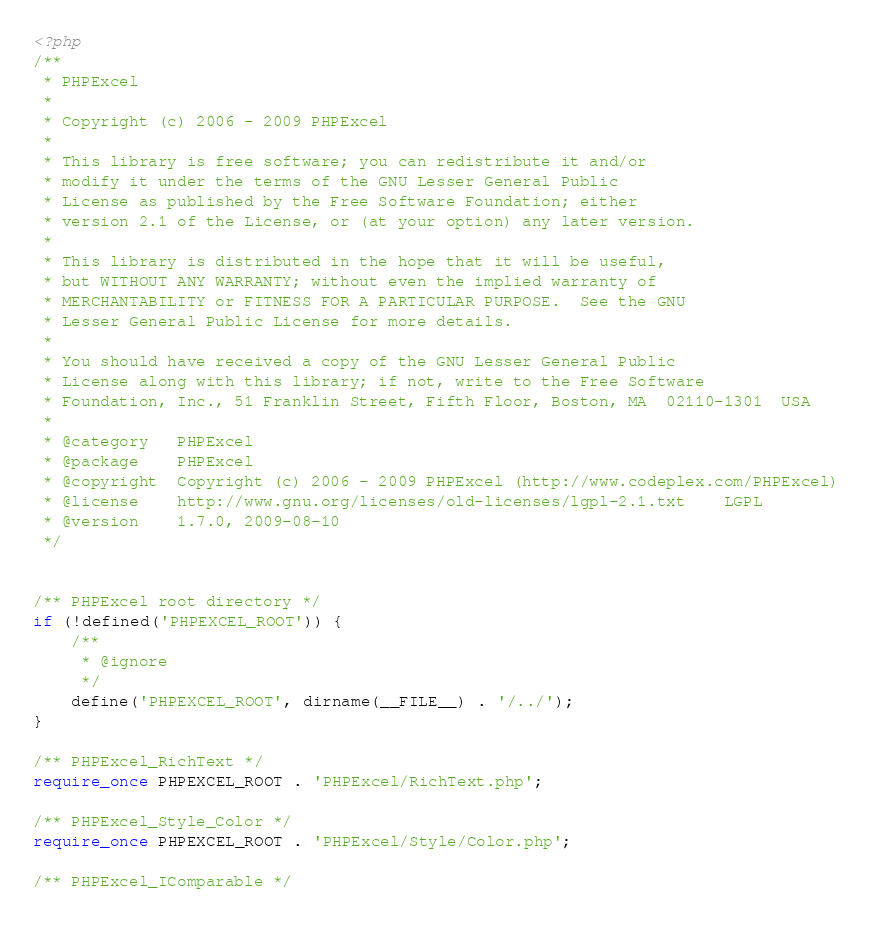<code> <loc_0><loc_0><loc_500><loc_500><_PHP_><?php
/**
 * PHPExcel
 *
 * Copyright (c) 2006 - 2009 PHPExcel
 *
 * This library is free software; you can redistribute it and/or
 * modify it under the terms of the GNU Lesser General Public
 * License as published by the Free Software Foundation; either
 * version 2.1 of the License, or (at your option) any later version.
 * 
 * This library is distributed in the hope that it will be useful,
 * but WITHOUT ANY WARRANTY; without even the implied warranty of
 * MERCHANTABILITY or FITNESS FOR A PARTICULAR PURPOSE.  See the GNU
 * Lesser General Public License for more details.
 * 
 * You should have received a copy of the GNU Lesser General Public
 * License along with this library; if not, write to the Free Software
 * Foundation, Inc., 51 Franklin Street, Fifth Floor, Boston, MA  02110-1301  USA
 *
 * @category   PHPExcel
 * @package    PHPExcel
 * @copyright  Copyright (c) 2006 - 2009 PHPExcel (http://www.codeplex.com/PHPExcel)
 * @license    http://www.gnu.org/licenses/old-licenses/lgpl-2.1.txt	LGPL
 * @version    1.7.0, 2009-08-10
 */


/** PHPExcel root directory */
if (!defined('PHPEXCEL_ROOT')) {
	/**
	 * @ignore
	 */
	define('PHPEXCEL_ROOT', dirname(__FILE__) . '/../');
}

/** PHPExcel_RichText */
require_once PHPEXCEL_ROOT . 'PHPExcel/RichText.php';

/** PHPExcel_Style_Color */
require_once PHPEXCEL_ROOT . 'PHPExcel/Style/Color.php';

/** PHPExcel_IComparable */</code> 